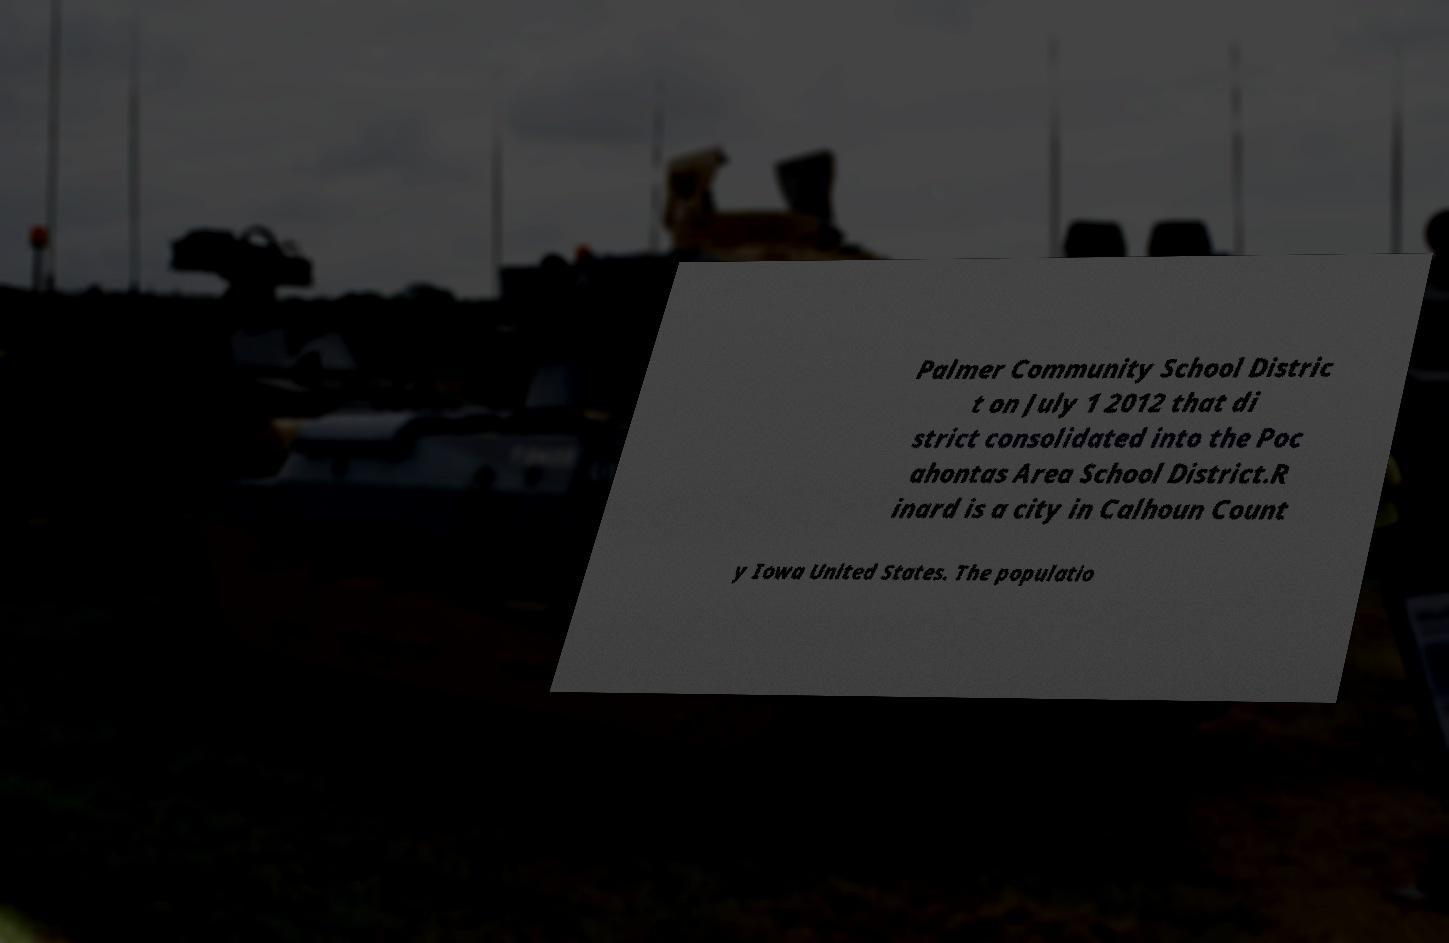Can you read and provide the text displayed in the image?This photo seems to have some interesting text. Can you extract and type it out for me? Palmer Community School Distric t on July 1 2012 that di strict consolidated into the Poc ahontas Area School District.R inard is a city in Calhoun Count y Iowa United States. The populatio 